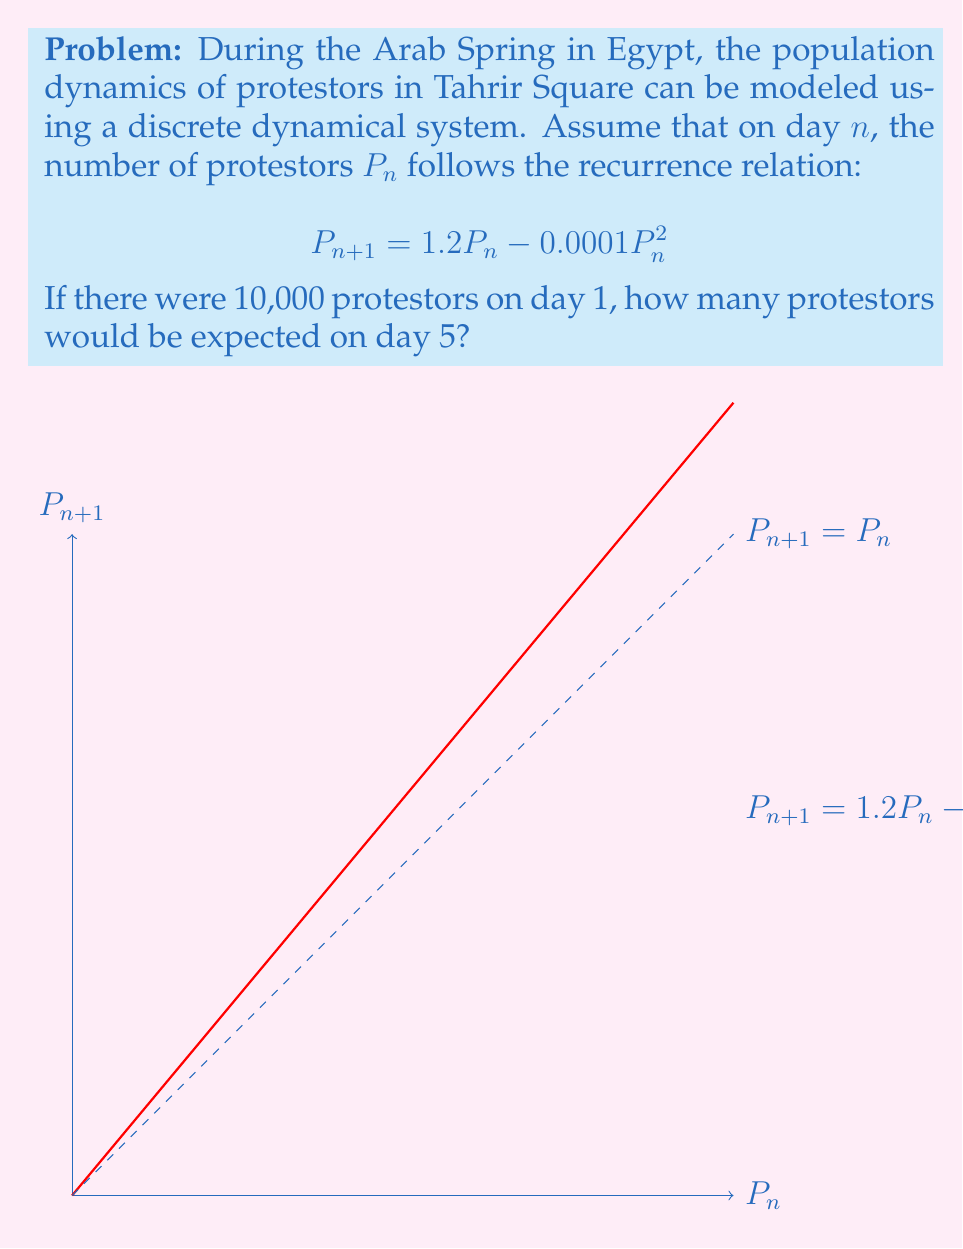Show me your answer to this math problem. To solve this problem, we need to iterate the recurrence relation for 5 days:

1) Start with $P_1 = 10,000$

2) For day 2:
   $$P_2 = 1.2(10,000) - 0.0001(10,000)^2 = 12,000 - 10,000 = 2,000$$

3) For day 3:
   $$P_3 = 1.2(2,000) - 0.0001(2,000)^2 = 2,400 - 400 = 2,000$$

4) For day 4:
   $$P_4 = 1.2(2,000) - 0.0001(2,000)^2 = 2,400 - 400 = 2,000$$

5) For day 5:
   $$P_5 = 1.2(2,000) - 0.0001(2,000)^2 = 2,400 - 400 = 2,000$$

We can observe that the population stabilizes at 2,000 protestors from day 3 onwards. This steady state occurs because at this point, $P_{n+1} = P_n = 2,000$.

We can verify this by substituting 2,000 into the original equation:
$$2,000 = 1.2(2,000) - 0.0001(2,000)^2$$
$$2,000 = 2,400 - 400 = 2,000$$

This demonstrates that 2,000 is indeed the equilibrium point for this system.
Answer: 2,000 protestors 